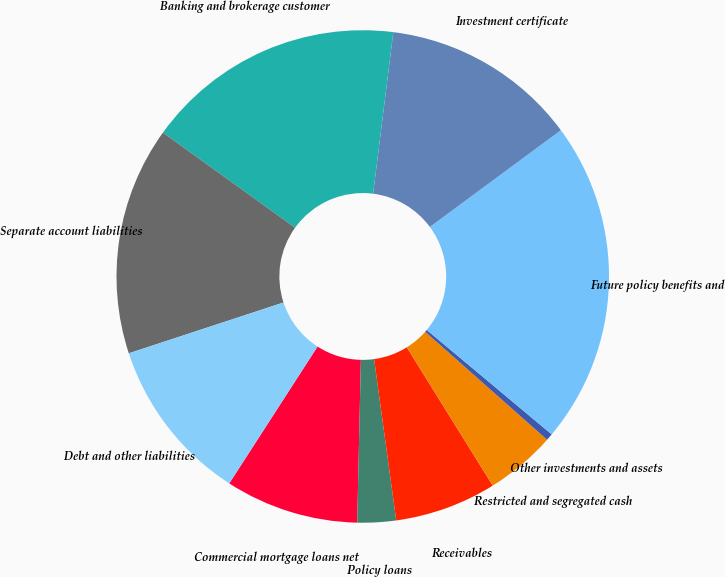Convert chart. <chart><loc_0><loc_0><loc_500><loc_500><pie_chart><fcel>Commercial mortgage loans net<fcel>Policy loans<fcel>Receivables<fcel>Restricted and segregated cash<fcel>Other investments and assets<fcel>Future policy benefits and<fcel>Investment certificate<fcel>Banking and brokerage customer<fcel>Separate account liabilities<fcel>Debt and other liabilities<nl><fcel>8.76%<fcel>2.53%<fcel>6.68%<fcel>4.61%<fcel>0.46%<fcel>21.2%<fcel>12.9%<fcel>17.05%<fcel>14.98%<fcel>10.83%<nl></chart> 